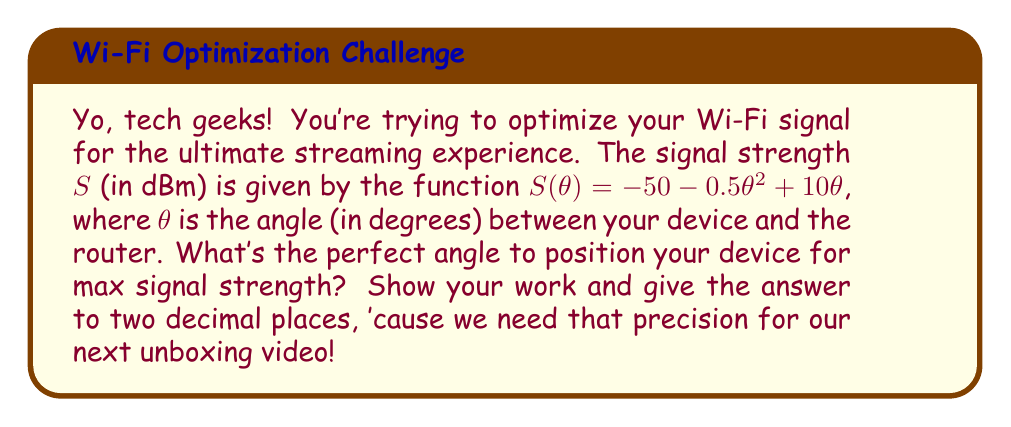Can you answer this question? Alright, let's break this down step-by-step:

1) To find the maximum signal strength, we need to find the angle $\theta$ where the derivative of $S(\theta)$ equals zero.

2) Let's start by finding the derivative of $S(\theta)$:

   $$\frac{d}{d\theta}S(\theta) = \frac{d}{d\theta}(-50 - 0.5\theta^2 + 10\theta)$$
   $$S'(\theta) = -\theta + 10$$

3) Now, we set this equal to zero and solve for $\theta$:

   $$-\theta + 10 = 0$$
   $$-\theta = -10$$
   $$\theta = 10$$

4) To confirm this is a maximum (not a minimum), we can check the second derivative:

   $$S''(\theta) = -1$$

   Since this is negative, we confirm that $\theta = 10$ gives a maximum.

5) To get the answer to two decimal places, we simply write:

   $$\theta = 10.00\text{ degrees}$$
Answer: 10.00 degrees 